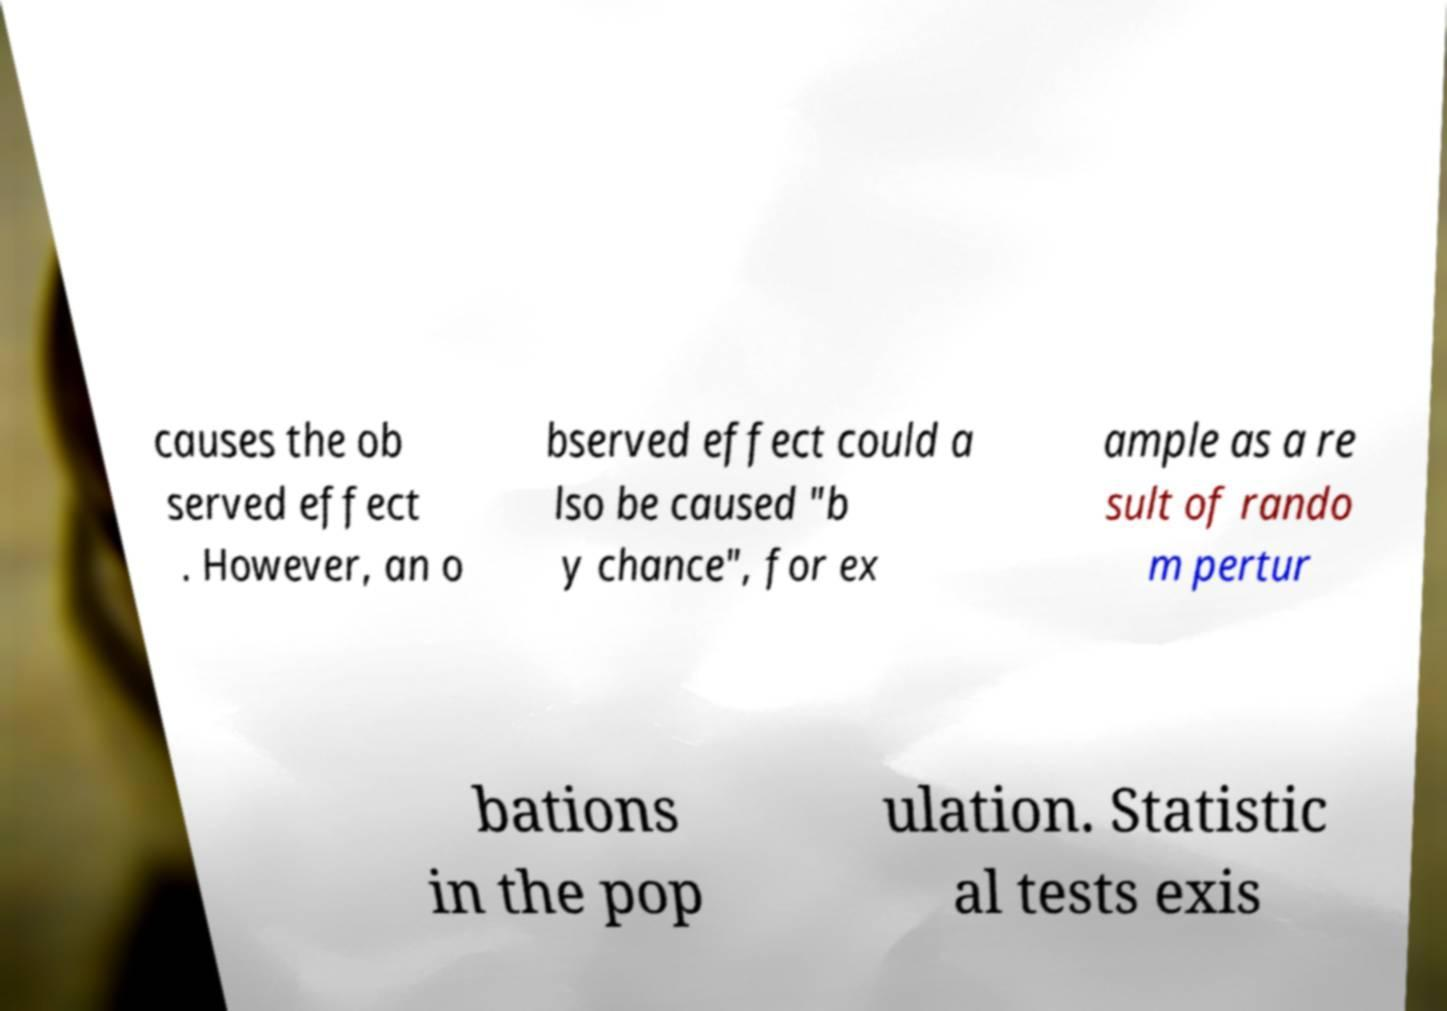I need the written content from this picture converted into text. Can you do that? causes the ob served effect . However, an o bserved effect could a lso be caused "b y chance", for ex ample as a re sult of rando m pertur bations in the pop ulation. Statistic al tests exis 